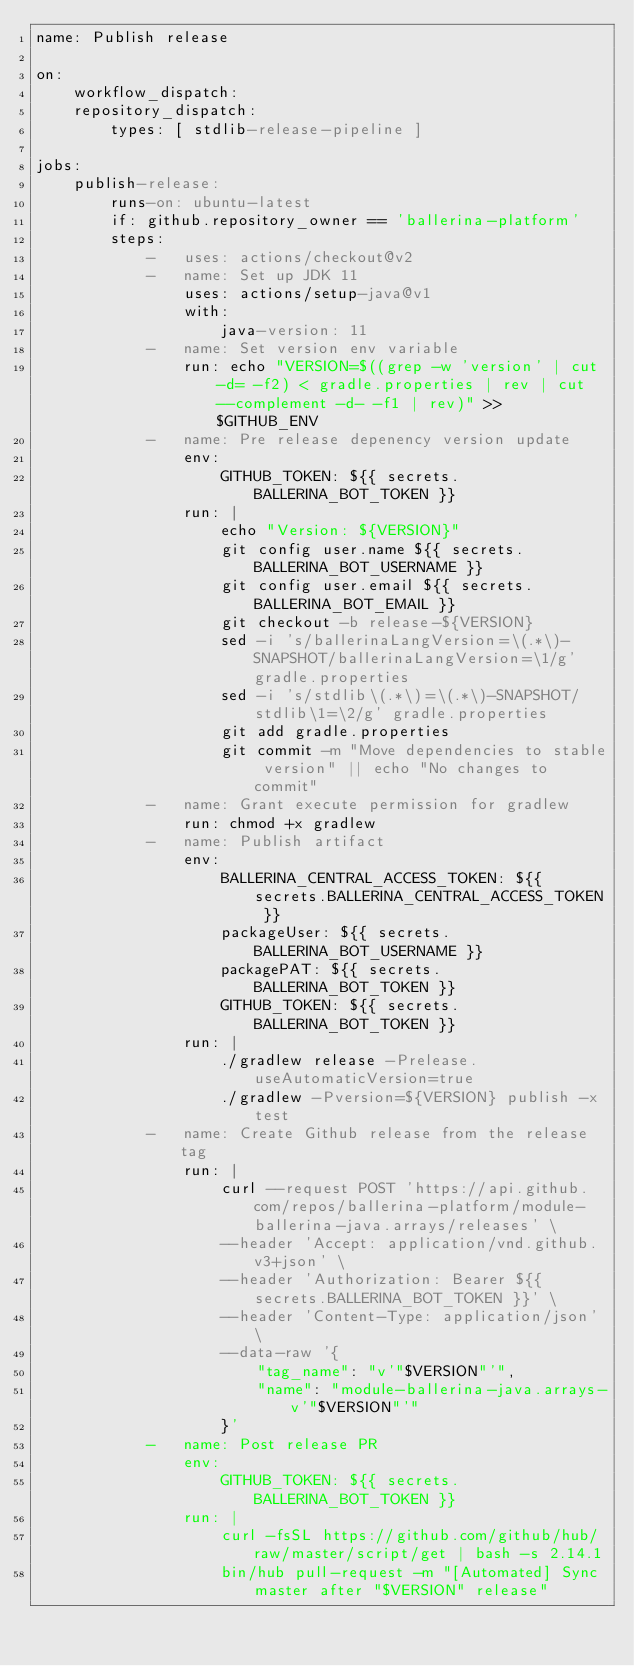<code> <loc_0><loc_0><loc_500><loc_500><_YAML_>name: Publish release

on:
    workflow_dispatch:
    repository_dispatch:
        types: [ stdlib-release-pipeline ]

jobs:
    publish-release:
        runs-on: ubuntu-latest
        if: github.repository_owner == 'ballerina-platform'
        steps:
            -   uses: actions/checkout@v2
            -   name: Set up JDK 11
                uses: actions/setup-java@v1
                with:
                    java-version: 11
            -   name: Set version env variable
                run: echo "VERSION=$((grep -w 'version' | cut -d= -f2) < gradle.properties | rev | cut --complement -d- -f1 | rev)" >> $GITHUB_ENV
            -   name: Pre release depenency version update
                env:
                    GITHUB_TOKEN: ${{ secrets.BALLERINA_BOT_TOKEN }}
                run: |
                    echo "Version: ${VERSION}"
                    git config user.name ${{ secrets.BALLERINA_BOT_USERNAME }}
                    git config user.email ${{ secrets.BALLERINA_BOT_EMAIL }}
                    git checkout -b release-${VERSION}
                    sed -i 's/ballerinaLangVersion=\(.*\)-SNAPSHOT/ballerinaLangVersion=\1/g' gradle.properties
                    sed -i 's/stdlib\(.*\)=\(.*\)-SNAPSHOT/stdlib\1=\2/g' gradle.properties
                    git add gradle.properties
                    git commit -m "Move dependencies to stable version" || echo "No changes to commit"
            -   name: Grant execute permission for gradlew
                run: chmod +x gradlew
            -   name: Publish artifact
                env:
                    BALLERINA_CENTRAL_ACCESS_TOKEN: ${{ secrets.BALLERINA_CENTRAL_ACCESS_TOKEN }}
                    packageUser: ${{ secrets.BALLERINA_BOT_USERNAME }}
                    packagePAT: ${{ secrets.BALLERINA_BOT_TOKEN }}
                    GITHUB_TOKEN: ${{ secrets.BALLERINA_BOT_TOKEN }}
                run: |
                    ./gradlew release -Prelease.useAutomaticVersion=true
                    ./gradlew -Pversion=${VERSION} publish -x test
            -   name: Create Github release from the release tag
                run: |
                    curl --request POST 'https://api.github.com/repos/ballerina-platform/module-ballerina-java.arrays/releases' \
                    --header 'Accept: application/vnd.github.v3+json' \
                    --header 'Authorization: Bearer ${{ secrets.BALLERINA_BOT_TOKEN }}' \
                    --header 'Content-Type: application/json' \
                    --data-raw '{
                        "tag_name": "v'"$VERSION"'",
                        "name": "module-ballerina-java.arrays-v'"$VERSION"'"
                    }'
            -   name: Post release PR
                env:
                    GITHUB_TOKEN: ${{ secrets.BALLERINA_BOT_TOKEN }}
                run: |
                    curl -fsSL https://github.com/github/hub/raw/master/script/get | bash -s 2.14.1
                    bin/hub pull-request -m "[Automated] Sync master after "$VERSION" release"
          
</code> 